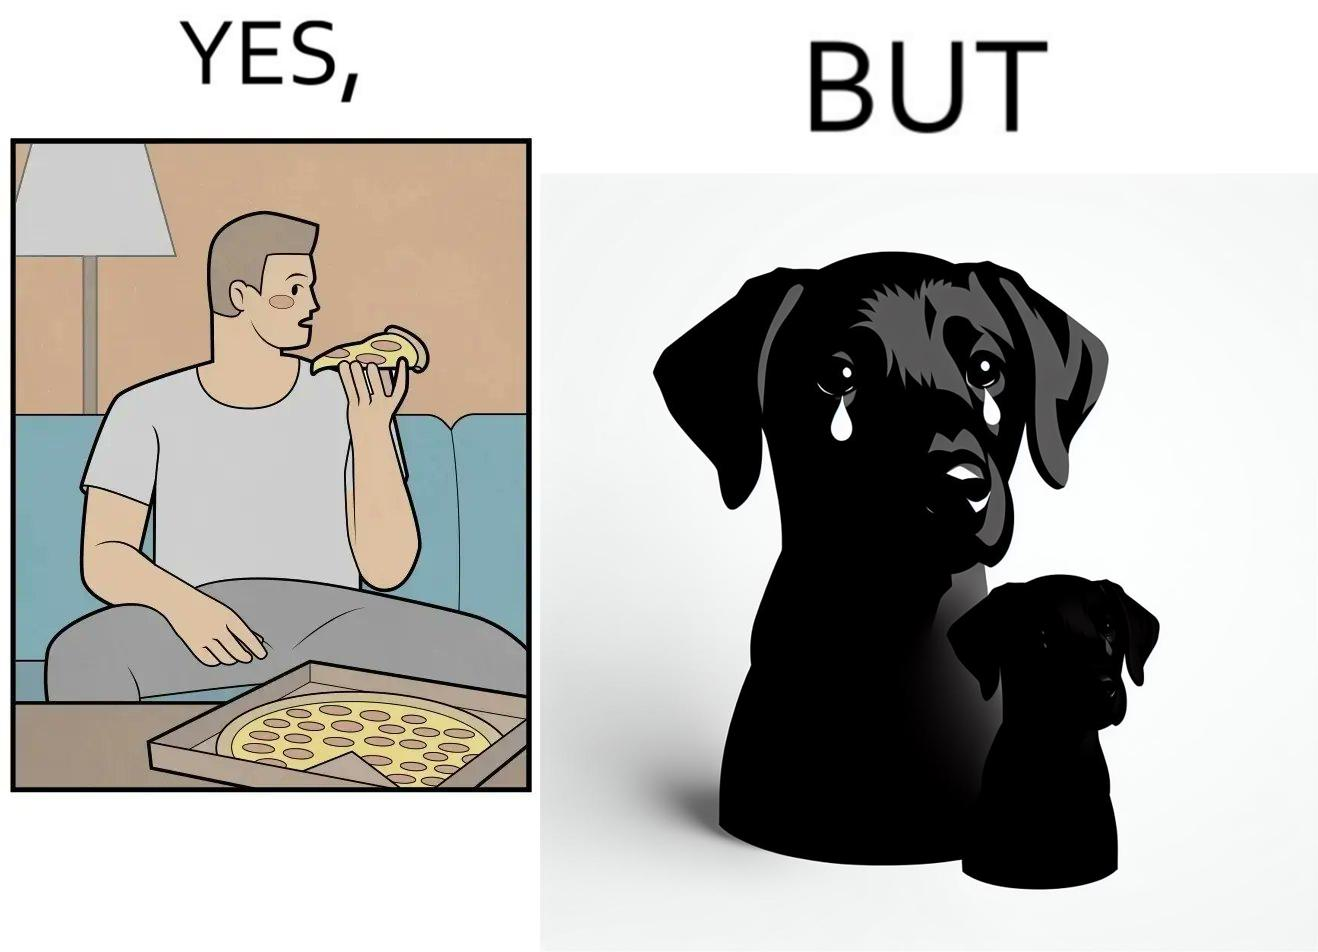Describe what you see in this image. The images are funny since they show how pet owners cannot enjoy any tasty food like pizza without sharing with their pets. The look from the pets makes the owner too guilty if he does not share his food 